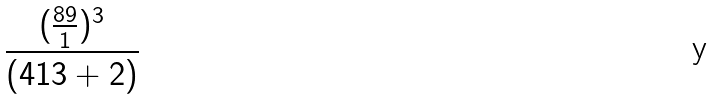Convert formula to latex. <formula><loc_0><loc_0><loc_500><loc_500>\frac { ( \frac { 8 9 } { 1 } ) ^ { 3 } } { ( 4 1 3 + 2 ) }</formula> 